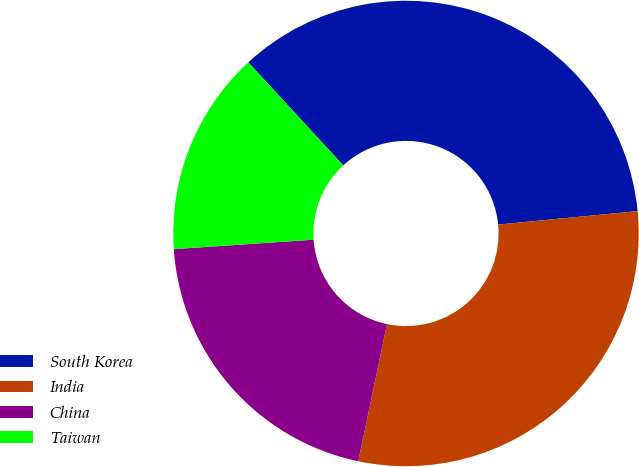Convert chart. <chart><loc_0><loc_0><loc_500><loc_500><pie_chart><fcel>South Korea<fcel>India<fcel>China<fcel>Taiwan<nl><fcel>35.32%<fcel>29.82%<fcel>20.64%<fcel>14.22%<nl></chart> 